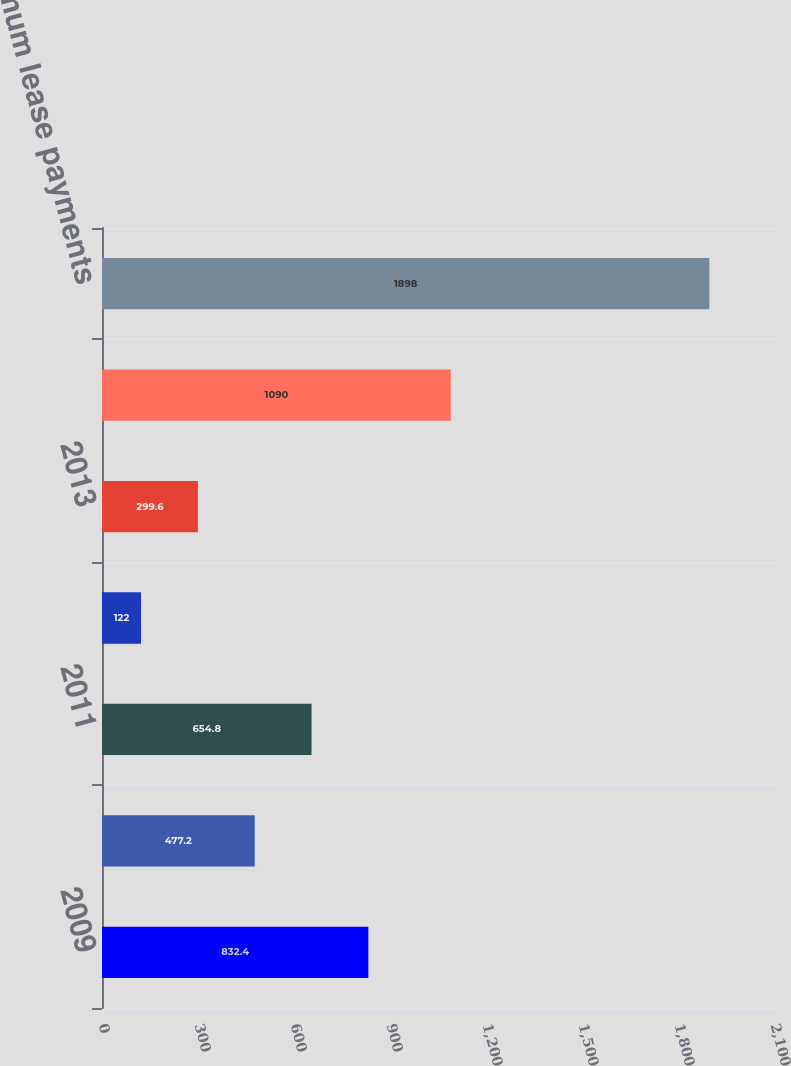<chart> <loc_0><loc_0><loc_500><loc_500><bar_chart><fcel>2009<fcel>2010<fcel>2011<fcel>2012<fcel>2013<fcel>Later years<fcel>Total minimum lease payments<nl><fcel>832.4<fcel>477.2<fcel>654.8<fcel>122<fcel>299.6<fcel>1090<fcel>1898<nl></chart> 